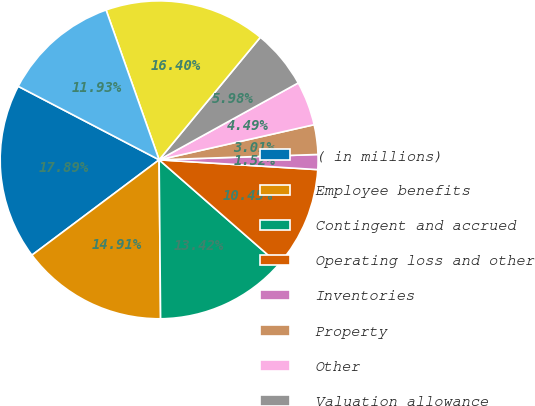Convert chart. <chart><loc_0><loc_0><loc_500><loc_500><pie_chart><fcel>( in millions)<fcel>Employee benefits<fcel>Contingent and accrued<fcel>Operating loss and other<fcel>Inventories<fcel>Property<fcel>Other<fcel>Valuation allowance<fcel>Total<fcel>Intangibles<nl><fcel>17.89%<fcel>14.91%<fcel>13.42%<fcel>10.45%<fcel>1.52%<fcel>3.01%<fcel>4.49%<fcel>5.98%<fcel>16.4%<fcel>11.93%<nl></chart> 